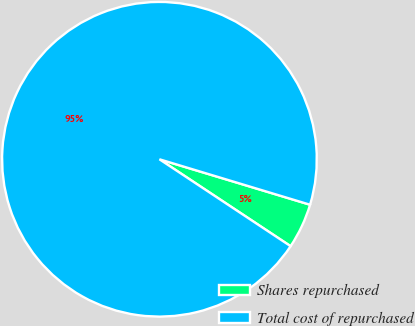Convert chart. <chart><loc_0><loc_0><loc_500><loc_500><pie_chart><fcel>Shares repurchased<fcel>Total cost of repurchased<nl><fcel>4.65%<fcel>95.35%<nl></chart> 